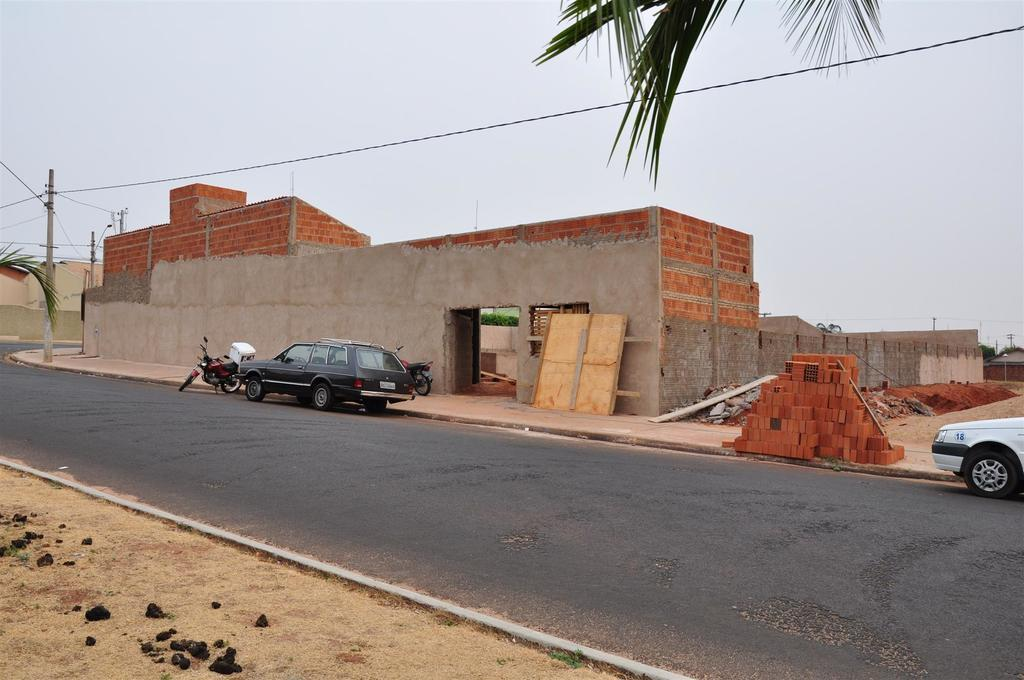What can be seen on the road in the image? There are vehicles on the road in the image. What type of structures can be seen in the background of the image? There are bricks, a gray-colored building, and an electric pole visible in the background of the image. What type of vegetation is present in the background of the image? There are green-colored trees in the background of the image. What is visible in the sky in the image? The sky is visible in the background of the image, and it appears to be gray in color. What invention is being demonstrated in the image? There is no invention being demonstrated in the image; it shows vehicles on the road, structures, and vegetation in the background, and a gray sky. What type of paint is used on the trees in the image? The trees in the image are not painted; they are natural and green in color. 